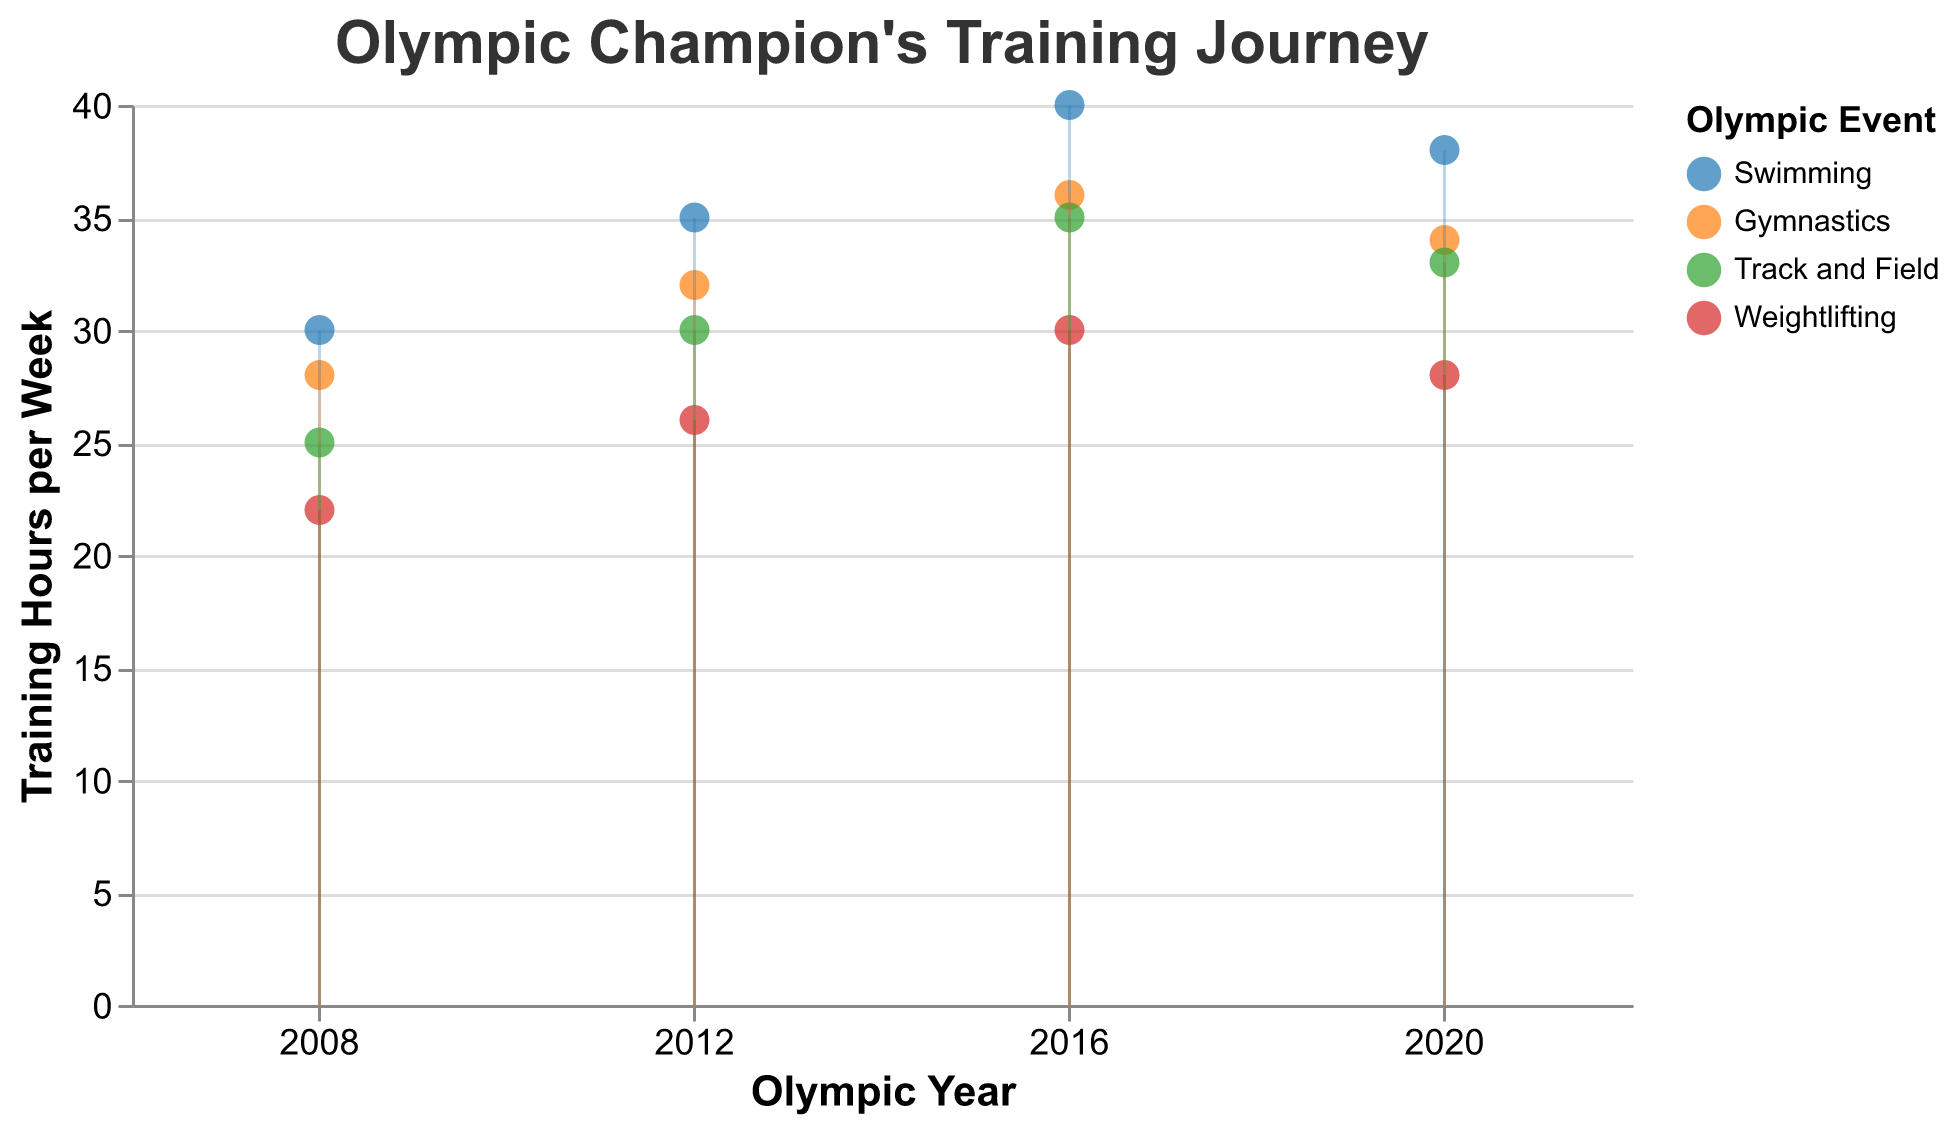How many different Olympic events are shown in the figure? The figure includes data points for four different events as indicated by the colors representing Swimming, Gymnastics, Track and Field, and Weightlifting.
Answer: 4 What is the title of the figure? The title is displayed at the top of the chart and reads "Olympic Champion's Training Journey".
Answer: Olympic Champion's Training Journey What is the range of training hours per week for Swimming from 2008 to 2020? To find the range, look at the data points for Swimming. The minimum value is 30 in 2008 and the maximum value is 40 in 2016. The range is 40 - 30.
Answer: 10 How did the training hours for Gymnastics change from 2008 to 2020? Look at the data points for Gymnastics from 2008 to 2020: 28 in 2008, 32 in 2012, 36 in 2016, and 34 in 2020. The training hours increased till 2016 and slightly decreased in 2020.
Answer: Increased then decreased Which event had the lowest training hours per week in 2008? Compare the training hours for all events in 2008: Swimming (30), Gymnastics (28), Track and Field (25), and Weightlifting (22). Weightlifting had the lowest training hours.
Answer: Weightlifting Between which consecutive Olympic years did Track and Field see the greatest increase in training hours per week? Check the changes in training hours for Track and Field between consecutive years: 25 to 30 (2008-2012), 30 to 35 (2012-2016), and 35 to 33 (2016-2020). The greatest increase was between 2012 and 2016.
Answer: 2012-2016 Which event has the most consistent training hours over the years, and what does that suggest about the training regimen? Compare the variability of the training hours for the four events. Weightlifting shows smaller increments and a more consistent pattern: 22 to 26, 26 to 30, and 30 to 28. This suggests a relatively stable training regimen.
Answer: Weightlifting, consistent What is the average weekly training hours for Swimming over the four recorded years? Add the training hours for Swimming (2008: 30, 2012: 35, 2016: 40, 2020: 38) and divide by the number of years. (30 + 35 + 40 + 38) / 4 = 143 / 4 = 35.75
Answer: 35.75 How do the training hours in 2020 compare between Gymnastics and Track and Field? Compare the 2020 data points: Gymnastics (34) and Track and Field (33). Training hours for Gymnastics are slightly higher.
Answer: Gymnastics > Track and Field 